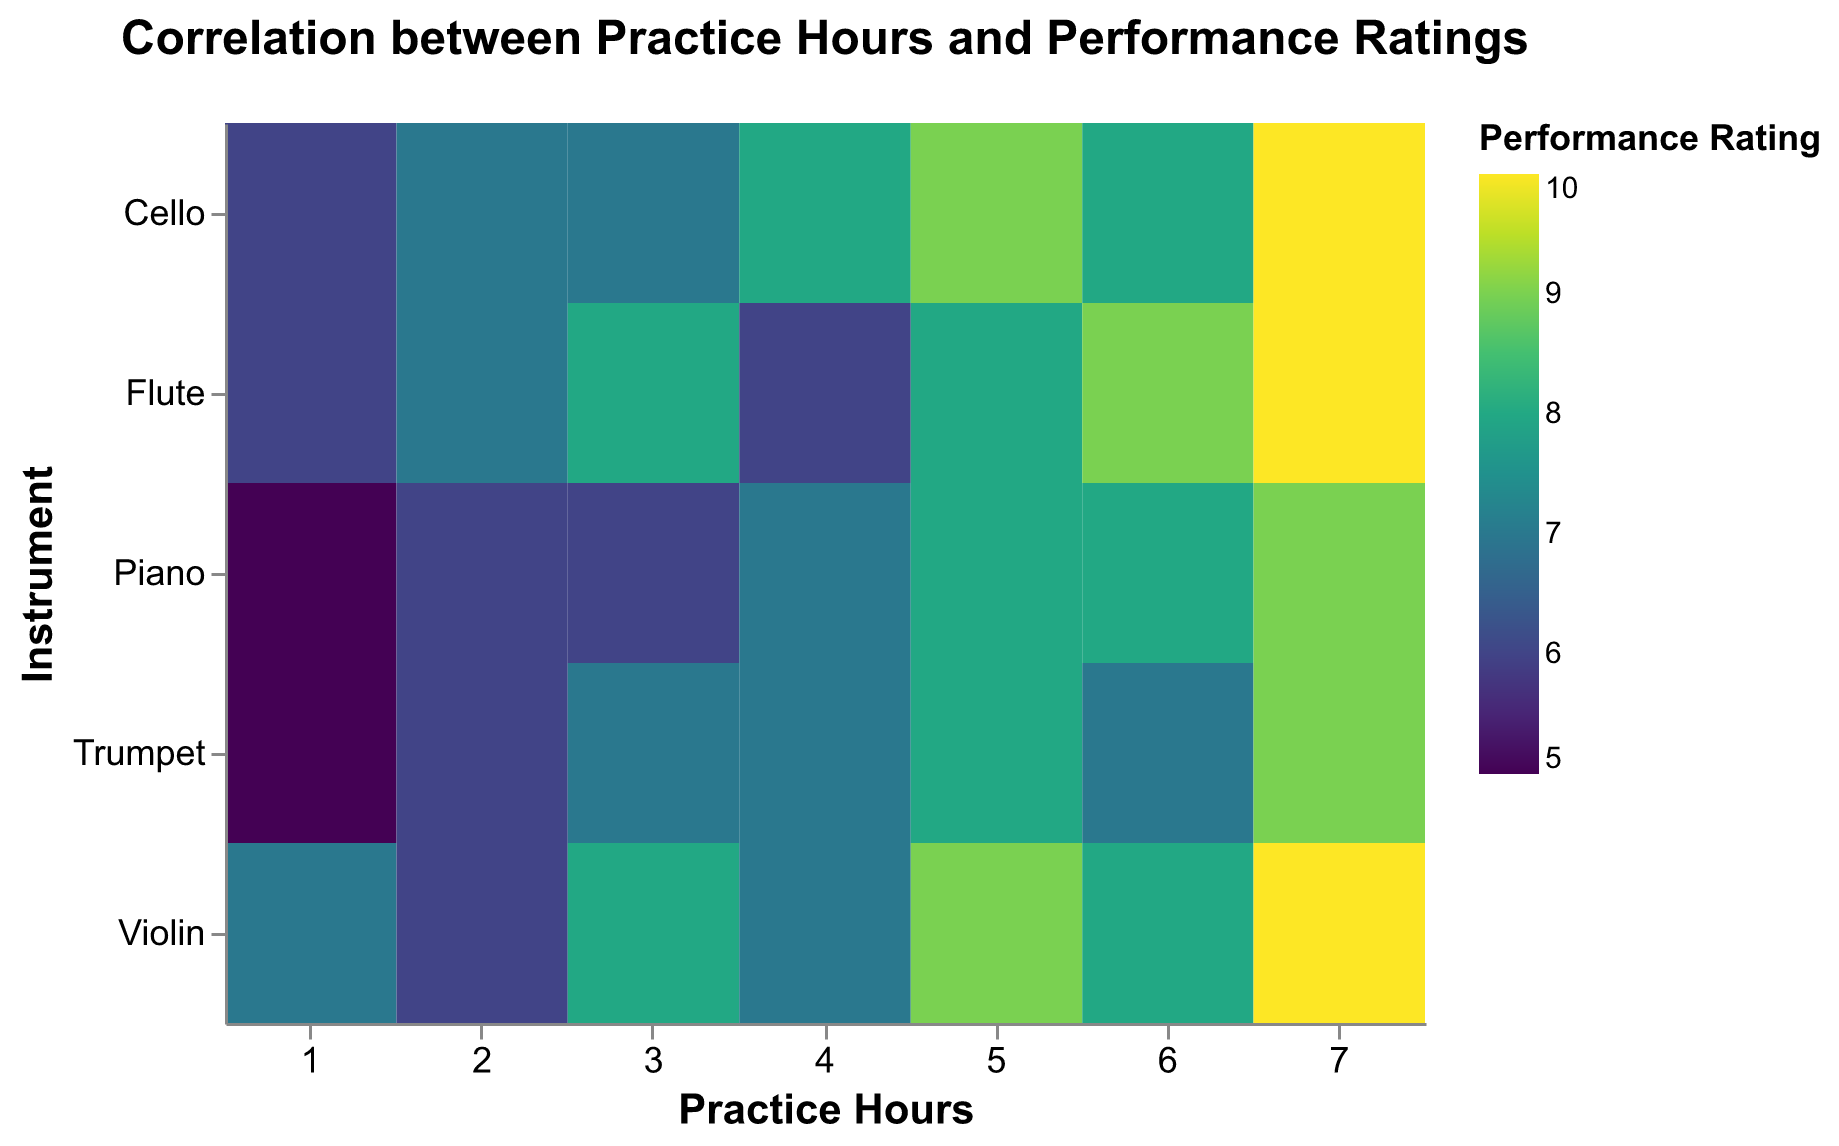How many practice hours are represented in the heatmap? Observe the x-axis labeled "Practice Hours" and count the number of different ticks or values. There are 7 distinct practice hour values (1 to 7).
Answer: 7 Which instrument has the highest performance rating with 5 hours of practice? Look at the column under "Practice Hours" for 5 and identify the highest color intensity in that column. The 'Violin' has the highest rating with a score of 9.
Answer: Violin How does the performance rating of the Piano change from 1 to 7 practice hours? Refer to the row labeled "Piano" and compare the colors across the "Practice Hours" from 1 to 7. The ratings go from 5, 6, 6, 7, 8, 8, to 9 respectively.
Answer: Increases from 5 to 9 Are there any instruments that have a performance rating of 10? Scan the color legend to identify the color corresponding to a rating of 10. Then, find this color in the heatmap. Both 'Violin' and 'Cello' have ratings of 10 at 7 hours of practice.
Answer: Yes, Violin and Cello Compare the performance ratings at 4 practice hours for Cello and Flute. Which has a higher rating? Look at the column for 4 practice hours and compare the colors of the 'Cello' and 'Flute' rows. Cello is 8 and Flute is 6. So, Cello has the higher rating.
Answer: Cello What is the average performance rating for the Trumpet across all practice hours? Add all the performance ratings for Trumpet from 1 to 7 hours (5, 6, 7, 7, 8, 7, 9) and divide by the number of hours (7). (5+6+7+7+8+7+9)/7 = 7
Answer: 7 Which practice hour is most frequently associated with a performance rating of 8? Identify all the instances where the color correspond to a rating of 8 and note their respective practice hours. Practice hours 5 and 6 have the most occurrences for the ratings of 8.
Answer: 5 and 6 Does the Flute show a consistent increase in performance with more practice hours? Examine the row for "Flute" and note the performance ratings: 6, 7, 8, 6, 8, 9, 10. The ratings slightly fluctuate, but generally increase. Thus, the increase is not perfectly consistent.
Answer: No Compare the trend in performance ratings between Violin and Trumpet as practice hours increase. Look at the rows for 'Violin' and 'Trumpet' and compare the pattern of their color intensities from 1 to 7 hours. The Violin shows a general upward trend, while Trumpet fluctuates more.
Answer: Violin has a more consistent upward trend 